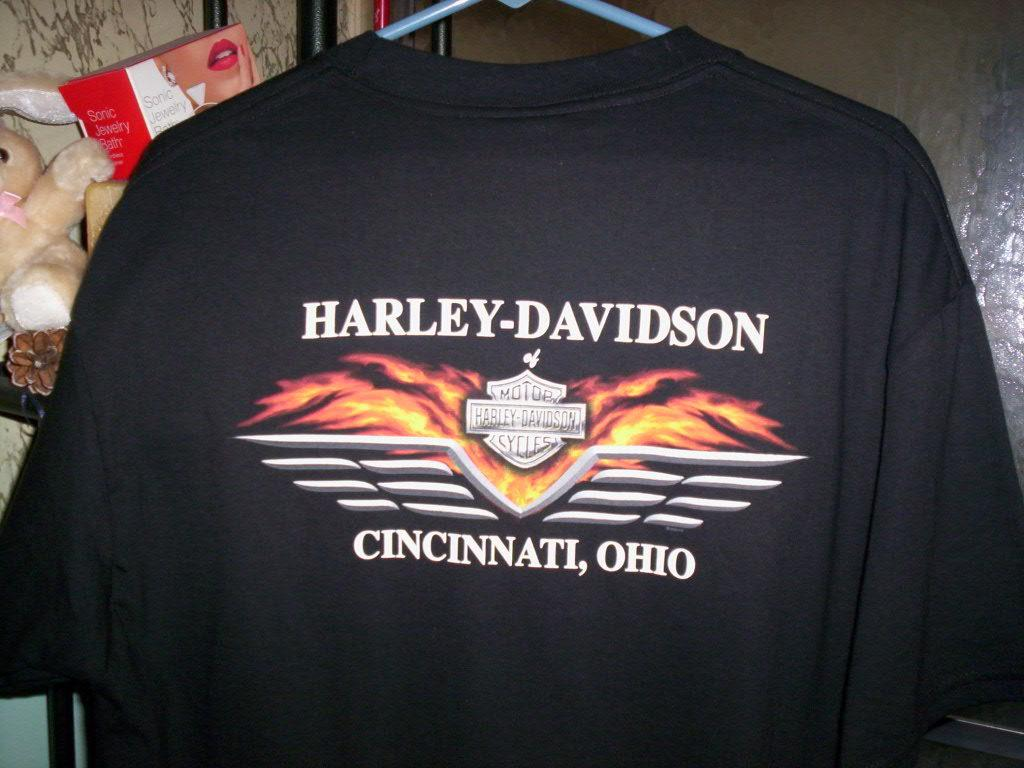<image>
Relay a brief, clear account of the picture shown. Black shirt sponsored by team Harley-Davidson in the state Ohio. 